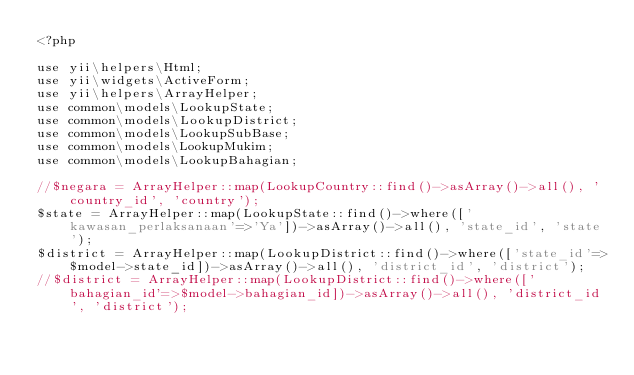<code> <loc_0><loc_0><loc_500><loc_500><_PHP_><?php

use yii\helpers\Html;
use yii\widgets\ActiveForm;
use yii\helpers\ArrayHelper;
use common\models\LookupState;
use common\models\LookupDistrict;
use common\models\LookupSubBase;
use common\models\LookupMukim;
use common\models\LookupBahagian;

//$negara = ArrayHelper::map(LookupCountry::find()->asArray()->all(), 'country_id', 'country');
$state = ArrayHelper::map(LookupState::find()->where(['kawasan_perlaksanaan'=>'Ya'])->asArray()->all(), 'state_id', 'state');
$district = ArrayHelper::map(LookupDistrict::find()->where(['state_id'=>$model->state_id])->asArray()->all(), 'district_id', 'district');
//$district = ArrayHelper::map(LookupDistrict::find()->where(['bahagian_id'=>$model->bahagian_id])->asArray()->all(), 'district_id', 'district');
</code> 